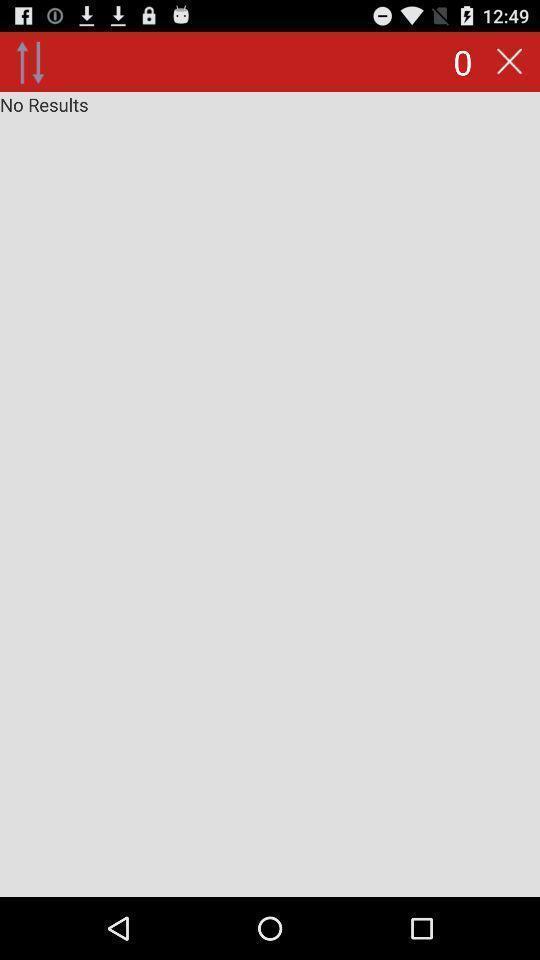What details can you identify in this image? Screen page displaying results not found. 